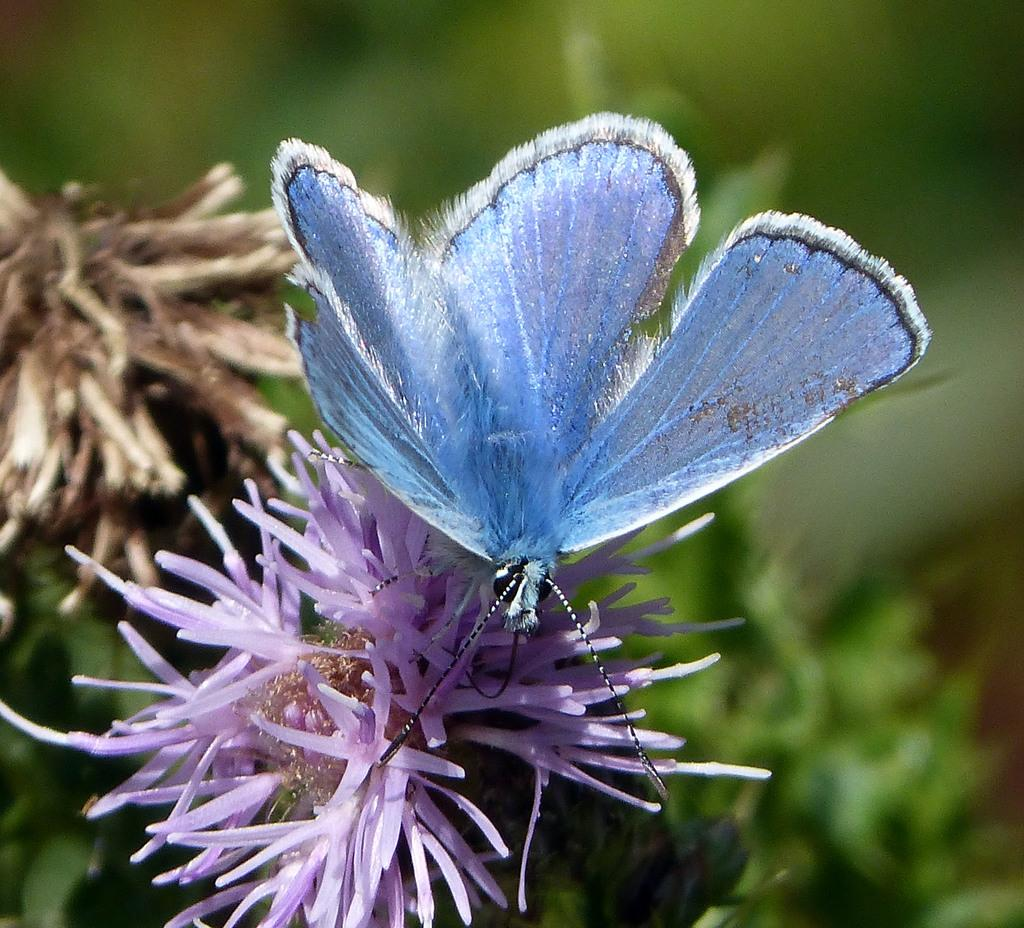What is the main subject of the image? There is a butterfly in the image. What is the butterfly doing in the image? The butterfly is standing on a flower. What can be seen in the background of the image? There is a group of trees in the background of the image. What type of canvas is the butterfly using to paint in the image? There is no canvas or painting activity present in the image; it features a butterfly standing on a flower. Can you tell me how many cars are visible in the image? There are no cars present in the image. 